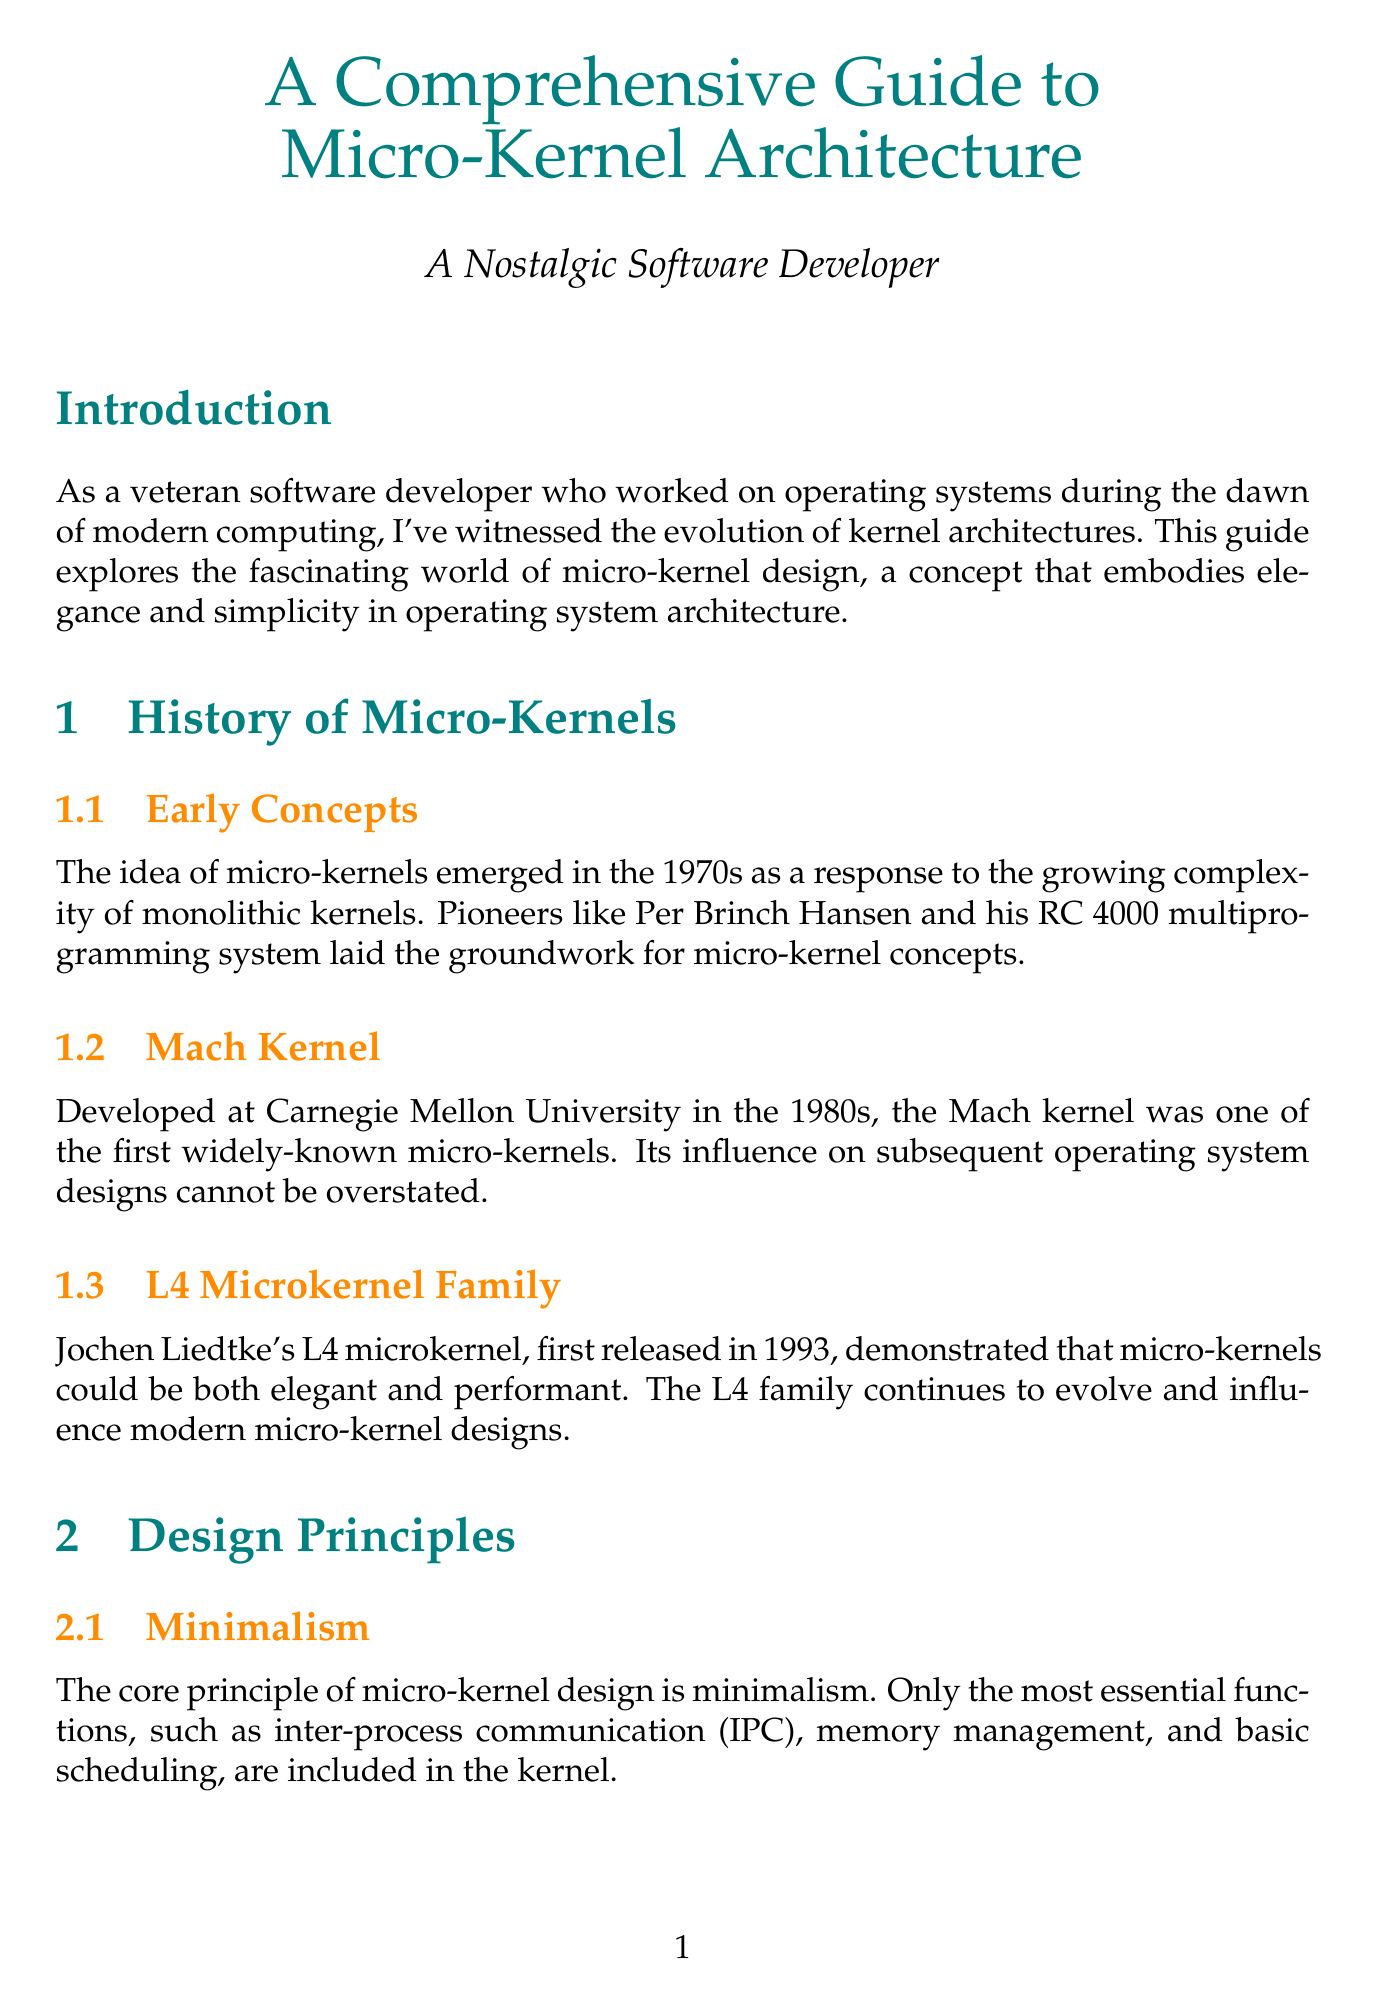What is the title of the document? The title is explicitly stated at the beginning of the document as the main heading.
Answer: A Comprehensive Guide to Micro-Kernel Architecture Who developed the Mach kernel? The document mentions Carnegie Mellon University as the institution where the Mach kernel was developed.
Answer: Carnegie Mellon University When was the L4 microkernel first released? The document specifies the year of the first release of the L4 microkernel.
Answer: 1993 What is the core principle of micro-kernel design? The document highlights minimalism as the fundamental principle of micro-kernel design.
Answer: Minimalism Which microkernel-based operating system is known for high reliability and fault tolerance? The document names Minix 3 as an example of a microkernel-based operating system that focuses on reliability.
Answer: Minix 3 What communication method is crucial for micro-kernels? The document identifies message passing as the essential communication method for micro-kernels.
Answer: Message Passing What is one challenge in micro-kernel implementation? The document lists performance overhead as one of the main challenges faced in implementing micro-kernels.
Answer: Performance Overhead Which microkernel is the first operating system kernel to be formally verified? The document refers to seL4 as the first operating system kernel that was formally verified.
Answer: seL4 What separation enhances system stability and security? The document states that running most system services in user space enhances stability and security.
Answer: User-Space Services 